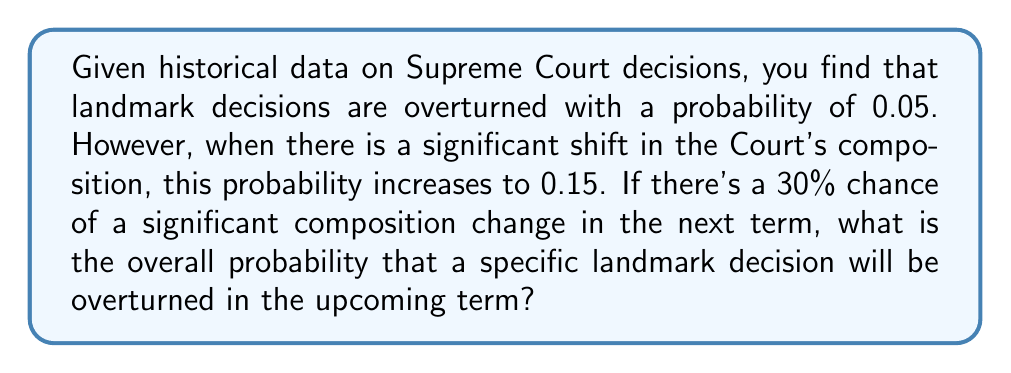Help me with this question. To solve this problem, we'll use the law of total probability. Let's define our events:

A: The landmark decision is overturned
B: There is a significant shift in the Court's composition

We're given:
$P(A|B) = 0.15$ (probability of overturning given a composition shift)
$P(A|\text{not }B) = 0.05$ (probability of overturning without a composition shift)
$P(B) = 0.30$ (probability of a composition shift)

The law of total probability states:

$$P(A) = P(A|B) \cdot P(B) + P(A|\text{not }B) \cdot P(\text{not }B)$$

We know $P(B) = 0.30$, so $P(\text{not }B) = 1 - 0.30 = 0.70$

Let's substitute the values:

$$\begin{aligned}
P(A) &= 0.15 \cdot 0.30 + 0.05 \cdot 0.70 \\
&= 0.045 + 0.035 \\
&= 0.08
\end{aligned}$$

Therefore, the overall probability of overturning the landmark decision is 0.08 or 8%.
Answer: 0.08 (or 8%) 